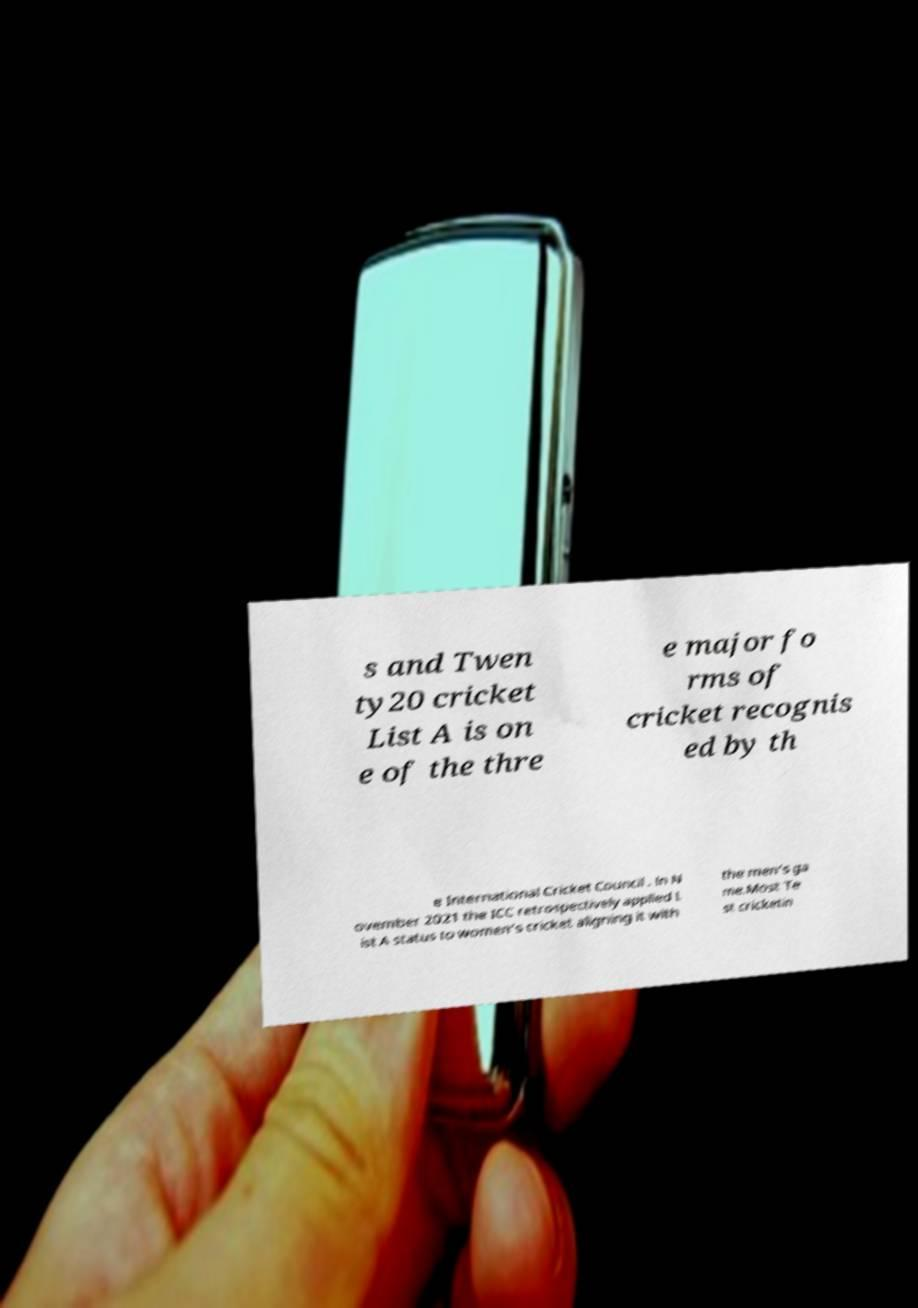Could you extract and type out the text from this image? s and Twen ty20 cricket List A is on e of the thre e major fo rms of cricket recognis ed by th e International Cricket Council . In N ovember 2021 the ICC retrospectively applied L ist A status to women's cricket aligning it with the men's ga me.Most Te st cricketin 